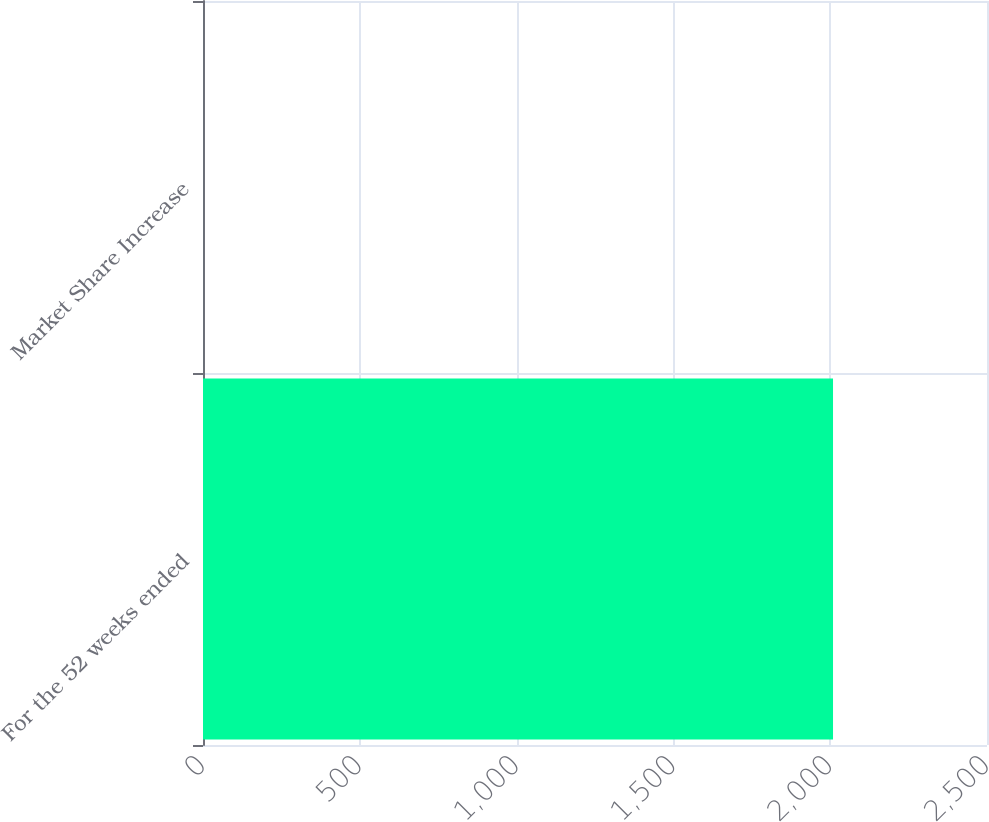Convert chart to OTSL. <chart><loc_0><loc_0><loc_500><loc_500><bar_chart><fcel>For the 52 weeks ended<fcel>Market Share Increase<nl><fcel>2009<fcel>0.1<nl></chart> 